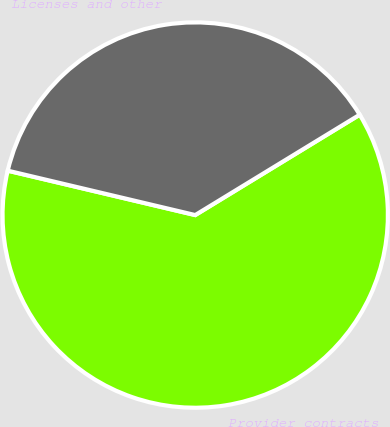Convert chart. <chart><loc_0><loc_0><loc_500><loc_500><pie_chart><fcel>Provider contracts<fcel>Licenses and other<nl><fcel>62.42%<fcel>37.58%<nl></chart> 